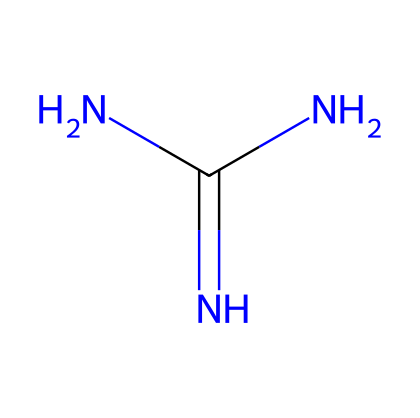How many nitrogen atoms are in guanidine? The SMILES representation shows three nitrogen atoms connected to the carbon atom. Each nitrogen is visible in the structure, confirming their count.
Answer: three What is the functional group present in guanidine? The presence of the amine group (–NH2) is indicated by the nitrogen atoms. These groups often contribute to basicity, typical for superbases.
Answer: amine What is the total number of hydrogen atoms in guanidine? By analyzing the nitrogen and carbon connectivity, we can determine that there are five hydrogen atoms connected to the three nitrogen atoms and one carbon atom, resulting in a total of five.
Answer: five Is guanidine a strong base? Guanidine's structure, particularly the three nitrogen atoms, allows it to effectively accept protons, categorizing it as a strong base due to its high basicity.
Answer: yes What type of substances are typically formed by guanidine? The basic properties of guanidine allow it to react with various substances, typically forming salts when it neutralizes acids. This reactivity is characteristic of superbases.
Answer: salts In which types of products is guanidine commonly used? Guanidine is frequently found in hair care products due to its strong basicity, which helps in altering hair structure, making it useful in styling and treatment products.
Answer: hair care products 